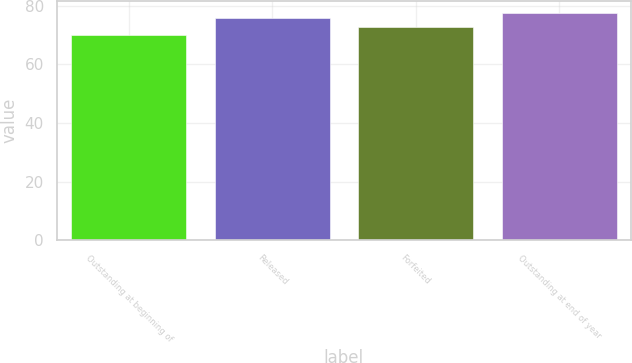<chart> <loc_0><loc_0><loc_500><loc_500><bar_chart><fcel>Outstanding at beginning of<fcel>Released<fcel>Forfeited<fcel>Outstanding at end of year<nl><fcel>70.19<fcel>75.9<fcel>72.81<fcel>77.7<nl></chart> 